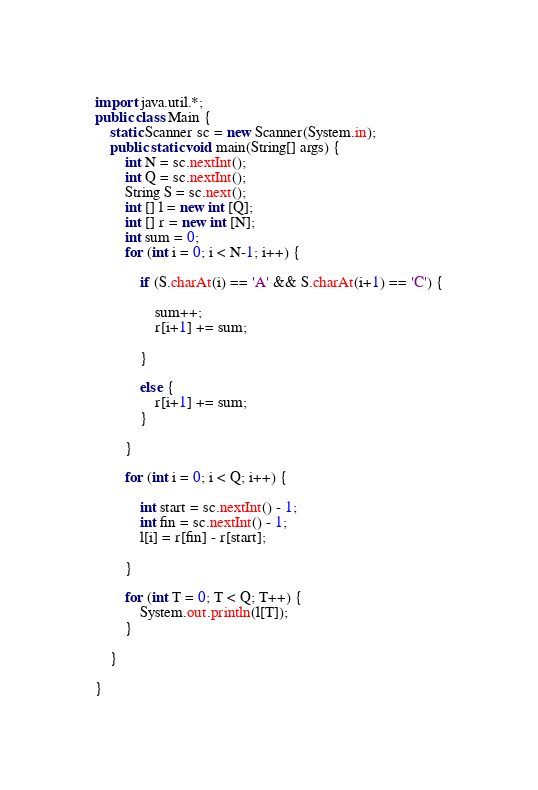<code> <loc_0><loc_0><loc_500><loc_500><_Java_>import java.util.*;
public class Main {
	static Scanner sc = new Scanner(System.in);
	public static void main(String[] args) {
		int N = sc.nextInt();
		int Q = sc.nextInt();
		String S = sc.next();
		int [] l = new int [Q];
		int [] r = new int [N];
		int sum = 0;
		for (int i = 0; i < N-1; i++) {
			
			if (S.charAt(i) == 'A' && S.charAt(i+1) == 'C') {
			
				sum++;
				r[i+1] += sum;
			
			} 
			
			else {
				r[i+1] += sum;
			}
		
		}
		
		for (int i = 0; i < Q; i++) {
		
			int start = sc.nextInt() - 1;
			int fin = sc.nextInt() - 1;
			l[i] = r[fin] - r[start];
			
		}
		
		for (int T = 0; T < Q; T++) {
			System.out.println(l[T]);
		}

	}	

}</code> 